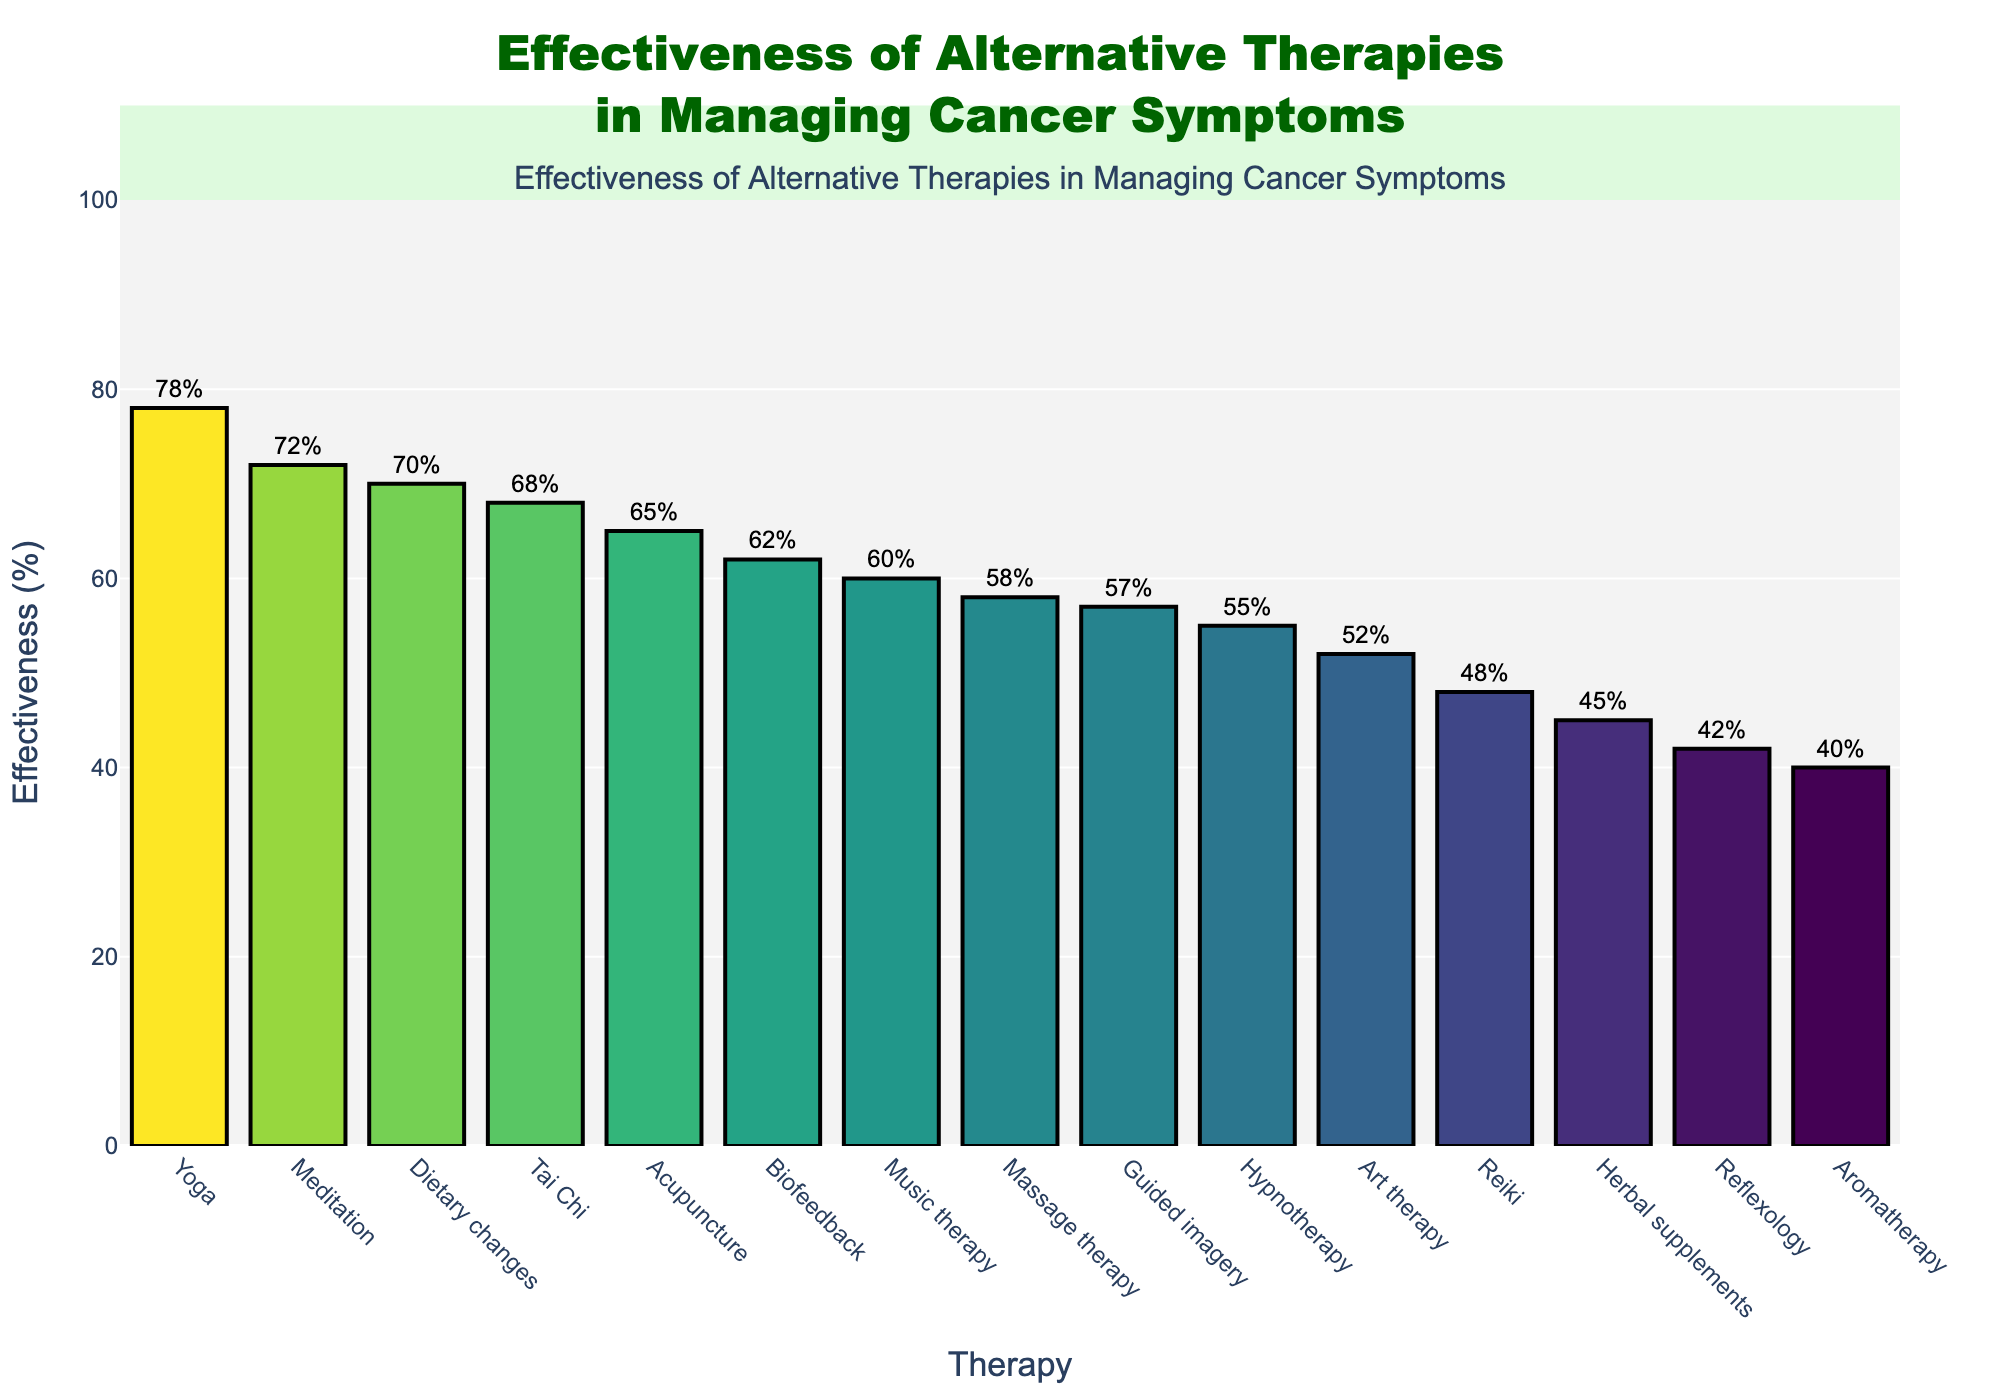What is the most effective therapy in managing cancer symptoms according to the chart? The chart shows bar heights corresponding to the effectiveness of each therapy. The tallest bar represents Yoga with an effectiveness of 78%.
Answer: Yoga Which therapy has the lowest effectiveness? By looking at the shortest bar on the chart, Aromatherapy has the lowest effectiveness at 40%.
Answer: Aromatherapy Compare the effectiveness of Yoga to Meditation. Yoga has an effectiveness of 78%, while Meditation has an effectiveness of 72%. Yoga is more effective by 6%.
Answer: Yoga is 6% more effective than Meditation Is the effectiveness of Hypnotherapy higher or lower than Reflexology? Hypnotherapy has an effectiveness of 55%, whereas Reflexology has an effectiveness of 42%. Hypnotherapy is higher by 13%.
Answer: Higher What is the average effectiveness of Acupuncture, Meditation, and Yoga? Acupuncture: 65%, Meditation: 72%, Yoga: 78%. Summing them up gives 65 + 72 + 78 = 215. Dividing by 3, the average is approximately 71.67%.
Answer: 71.67% How much more effective is Music Therapy compared to Aromatherapy? Music Therapy has an effectiveness of 60%, while Aromatherapy has 40%. The difference is 60 - 40 = 20%.
Answer: 20% What is the median effectiveness value of the therapies listed? List the values in ascending order: 40, 42, 45, 48, 52, 55, 57, 58, 60, 62, 65, 68, 70, 72, 78. With 15 data points, the median is the 8th value which is 58%.
Answer: 58% Which therapies have effectiveness greater than 60%? Therapies with effectiveness greater than 60% are: Yoga (78%), Meditation (72%), Dietary changes (70%), Tai Chi (68%), and Acupuncture (65%).
Answer: Yoga, Meditation, Dietary changes, Tai Chi, Acupuncture Compare the effectiveness of Herbal supplements and Biofeedback. Herbal supplements have an effectiveness of 45%, while Biofeedback is at 62%. Biofeedback is 17% more effective than Herbal supplements.
Answer: Biofeedback is 17% more effective 